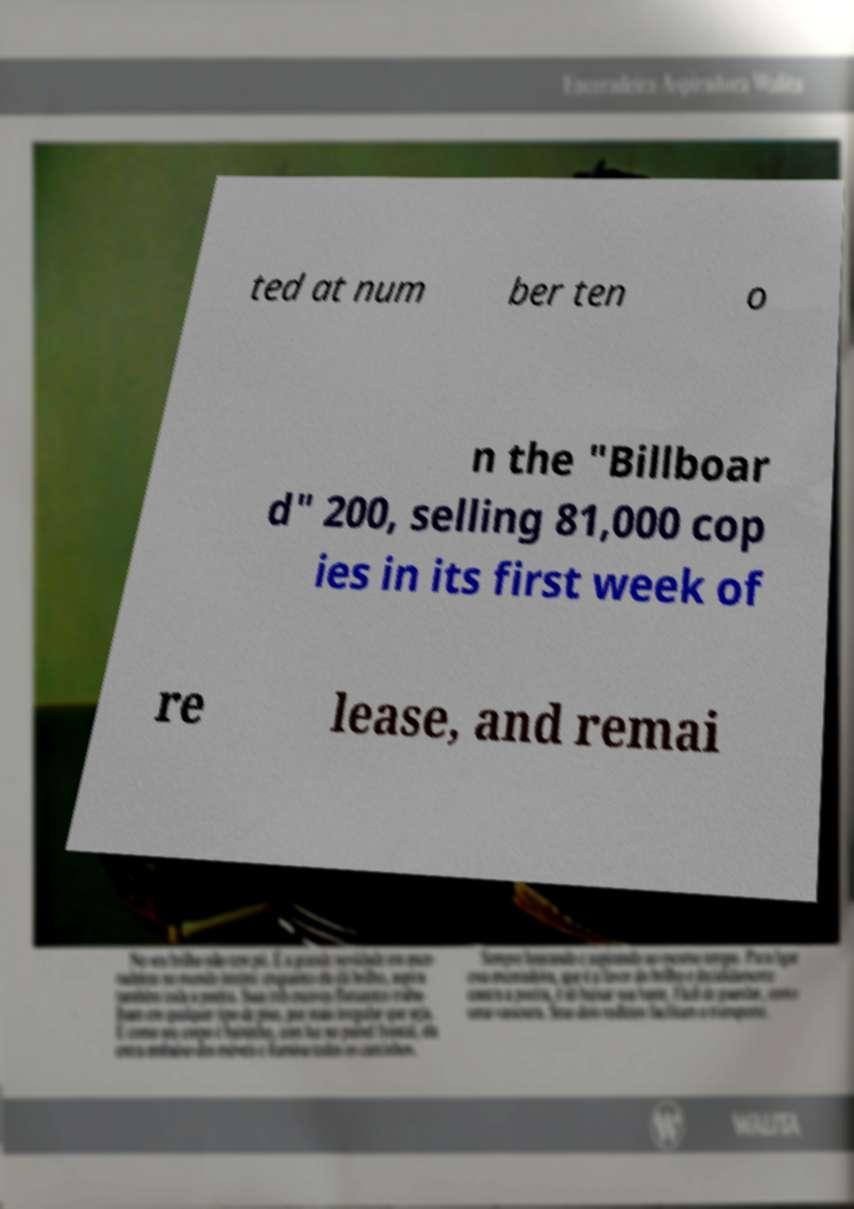For documentation purposes, I need the text within this image transcribed. Could you provide that? ted at num ber ten o n the "Billboar d" 200, selling 81,000 cop ies in its first week of re lease, and remai 